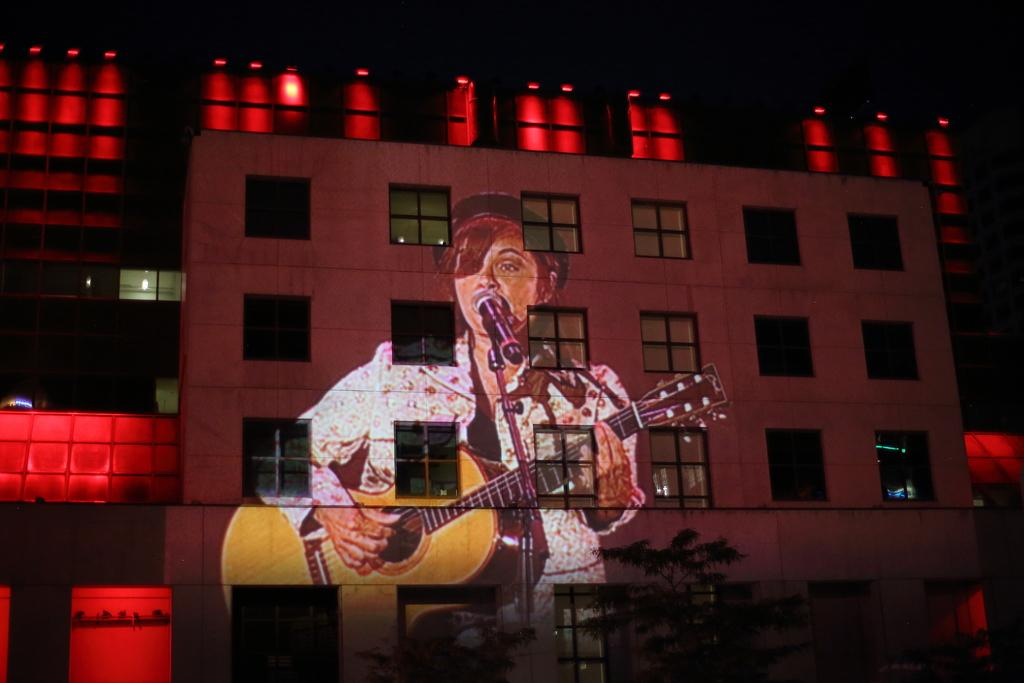What is the woman in the image doing? The woman is singing on a mic and playing a guitar. What can be seen on the wall in the image? There is a woman's image on the wall. What architectural features are visible in the image? There are windows and a building in the image. What type of lighting is present in the image? There are lights in the image. Can you tell me how many bridges are visible in the image? There are no bridges visible in the image. What type of parcel is being delivered to the woman in the image? There is no parcel being delivered to the woman in the image. 